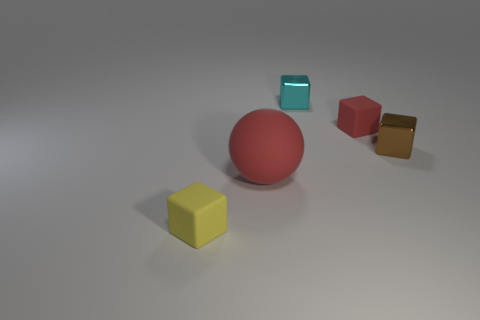Add 3 metal balls. How many objects exist? 8 Subtract all yellow balls. Subtract all red blocks. How many balls are left? 1 Subtract all blocks. How many objects are left? 1 Subtract 0 gray cubes. How many objects are left? 5 Subtract all small purple rubber objects. Subtract all tiny things. How many objects are left? 1 Add 3 small yellow objects. How many small yellow objects are left? 4 Add 4 gray metallic cylinders. How many gray metallic cylinders exist? 4 